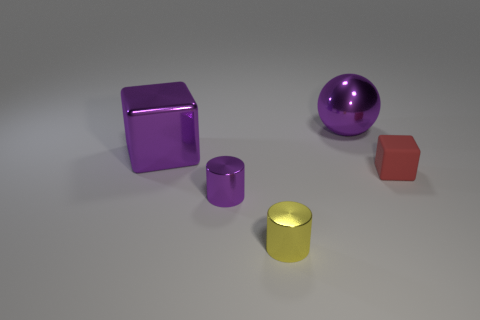There is a shiny cylinder that is the same color as the big ball; what size is it?
Your response must be concise. Small. Are there any large blocks that have the same color as the big sphere?
Provide a short and direct response. Yes. What is the shape of the big shiny thing that is the same color as the big block?
Make the answer very short. Sphere. Are there fewer tiny red matte blocks than green metal objects?
Your answer should be very brief. No. What is the shape of the small thing that is made of the same material as the yellow cylinder?
Provide a succinct answer. Cylinder. Are there any large purple metallic spheres left of the red matte thing?
Keep it short and to the point. Yes. Is the number of tiny purple cylinders that are to the right of the red rubber object less than the number of cyan shiny cubes?
Make the answer very short. No. What is the material of the red cube?
Your answer should be very brief. Rubber. The tiny rubber thing has what color?
Provide a succinct answer. Red. There is a thing that is right of the tiny yellow cylinder and to the left of the red thing; what color is it?
Your answer should be compact. Purple. 